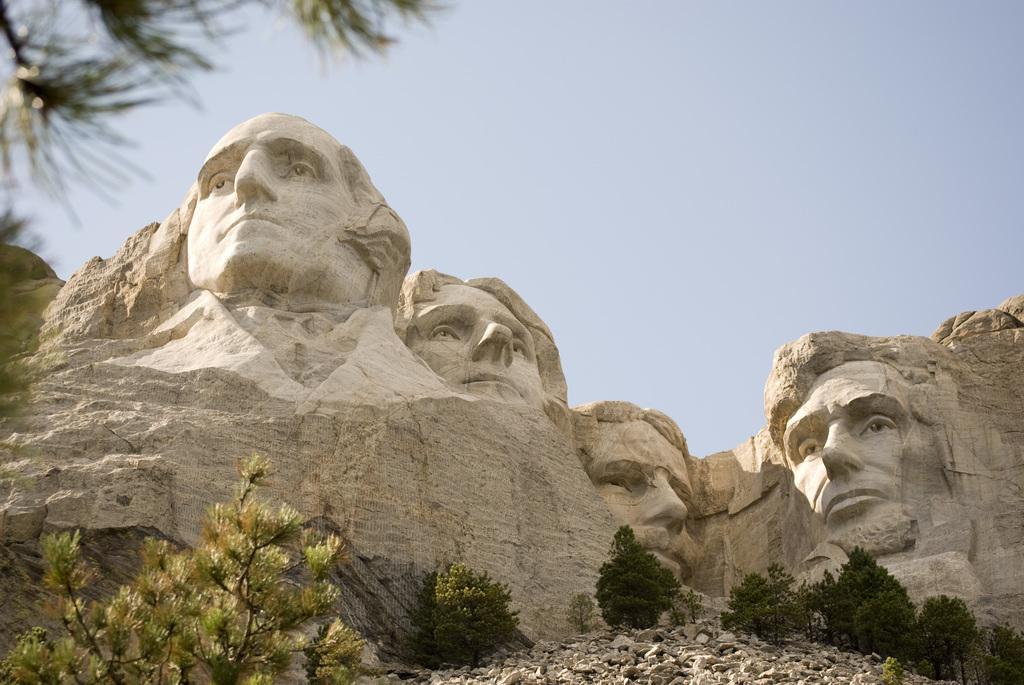Describe this image in one or two sentences. Bottom left side of the image there are some trees. Bottom right side of the image there are some stones. In the middle of the image there are some statues and hill. Top right side of the image there is sky. 